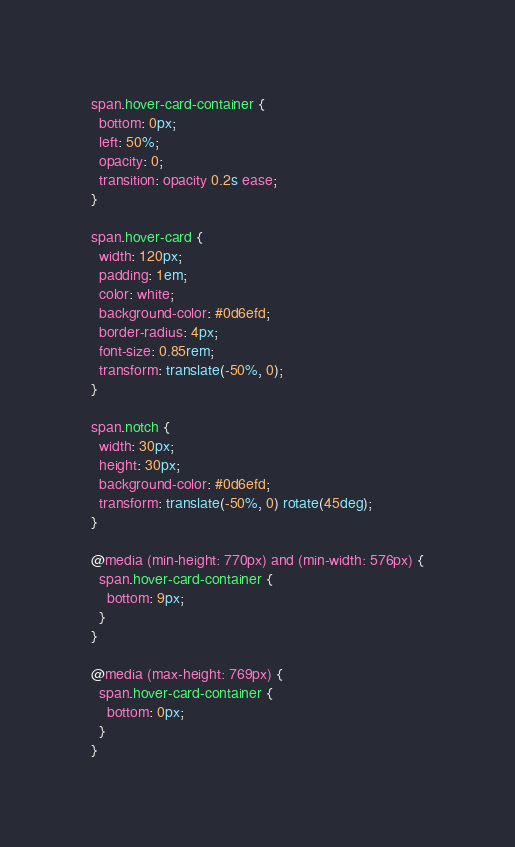<code> <loc_0><loc_0><loc_500><loc_500><_CSS_>span.hover-card-container {
  bottom: 0px;
  left: 50%;
  opacity: 0;
  transition: opacity 0.2s ease;
}

span.hover-card {
  width: 120px;
  padding: 1em;
  color: white;
  background-color: #0d6efd;
  border-radius: 4px;
  font-size: 0.85rem;
  transform: translate(-50%, 0);
}

span.notch {
  width: 30px;
  height: 30px;
  background-color: #0d6efd;
  transform: translate(-50%, 0) rotate(45deg);
}

@media (min-height: 770px) and (min-width: 576px) {
  span.hover-card-container {
    bottom: 9px;
  }
}

@media (max-height: 769px) {
  span.hover-card-container {
    bottom: 0px;
  }
}
</code> 